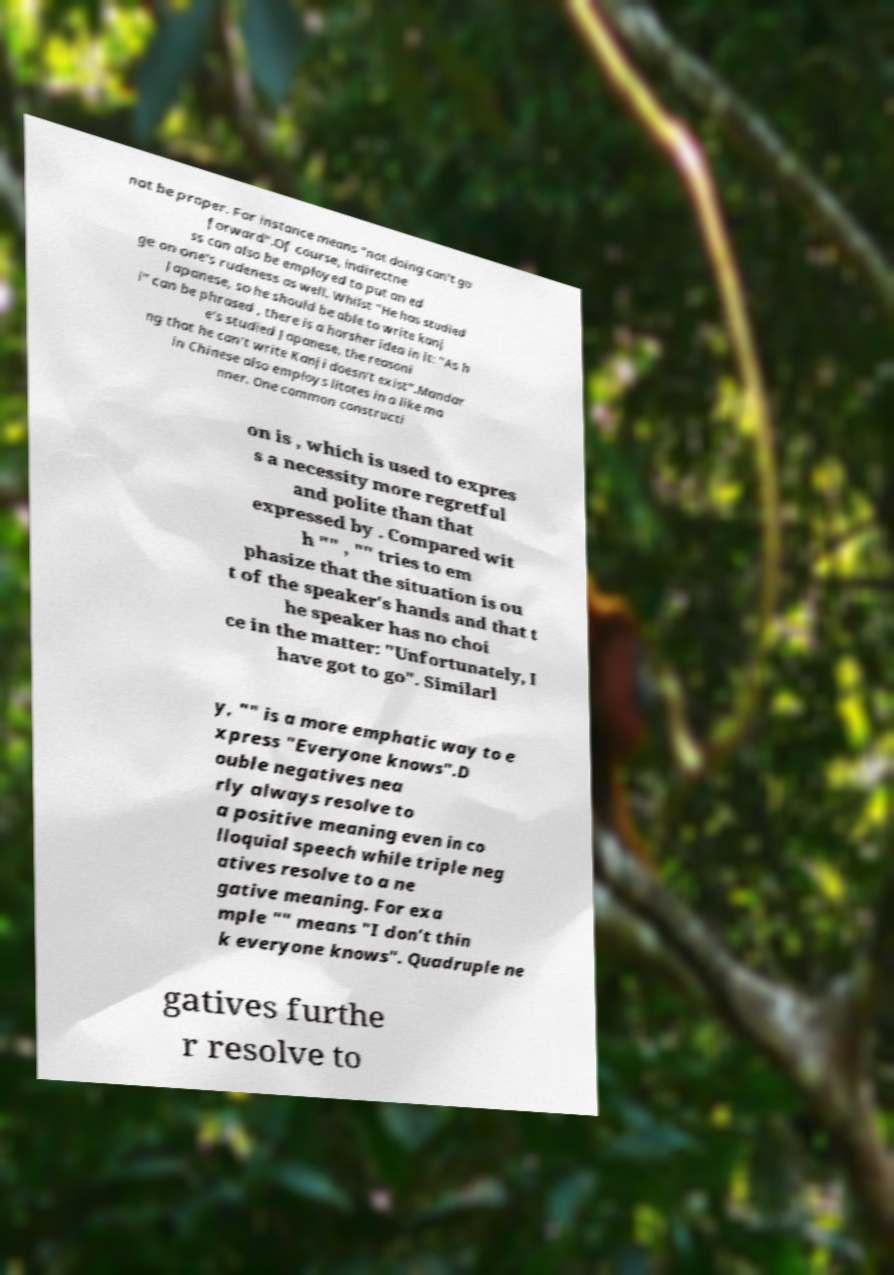I need the written content from this picture converted into text. Can you do that? not be proper. For instance means "not doing can't go forward".Of course, indirectne ss can also be employed to put an ed ge on one's rudeness as well. Whilst "He has studied Japanese, so he should be able to write kanj i" can be phrased , there is a harsher idea in it: "As h e's studied Japanese, the reasoni ng that he can't write Kanji doesn't exist".Mandar in Chinese also employs litotes in a like ma nner. One common constructi on is , which is used to expres s a necessity more regretful and polite than that expressed by . Compared wit h "" , "" tries to em phasize that the situation is ou t of the speaker's hands and that t he speaker has no choi ce in the matter: "Unfortunately, I have got to go". Similarl y, "" is a more emphatic way to e xpress "Everyone knows".D ouble negatives nea rly always resolve to a positive meaning even in co lloquial speech while triple neg atives resolve to a ne gative meaning. For exa mple "" means "I don't thin k everyone knows". Quadruple ne gatives furthe r resolve to 